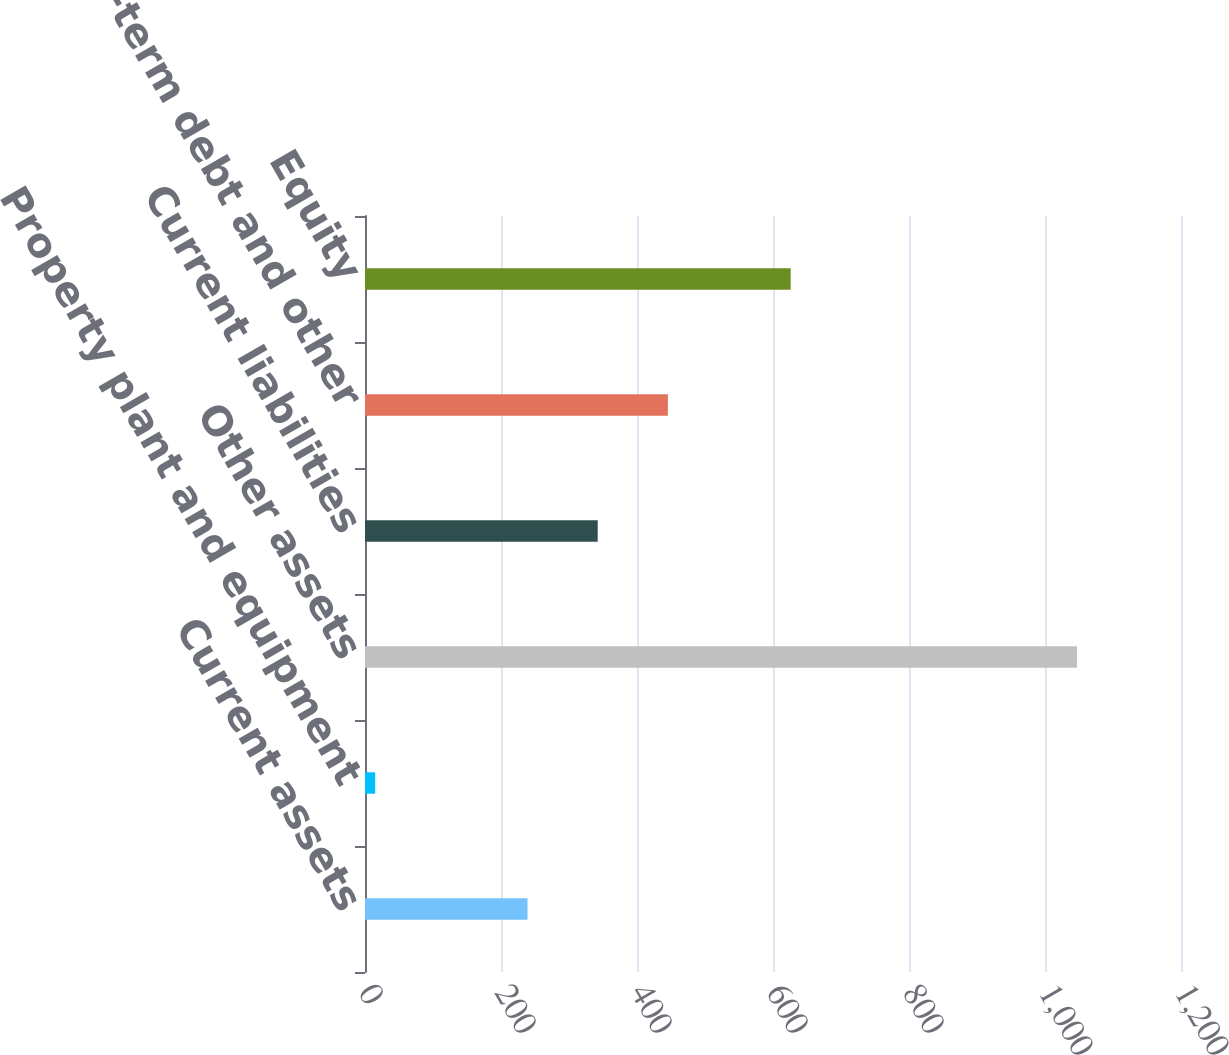<chart> <loc_0><loc_0><loc_500><loc_500><bar_chart><fcel>Current assets<fcel>Property plant and equipment<fcel>Other assets<fcel>Current liabilities<fcel>Long-term debt and other<fcel>Equity<nl><fcel>239<fcel>15<fcel>1047<fcel>342.2<fcel>445.4<fcel>626<nl></chart> 